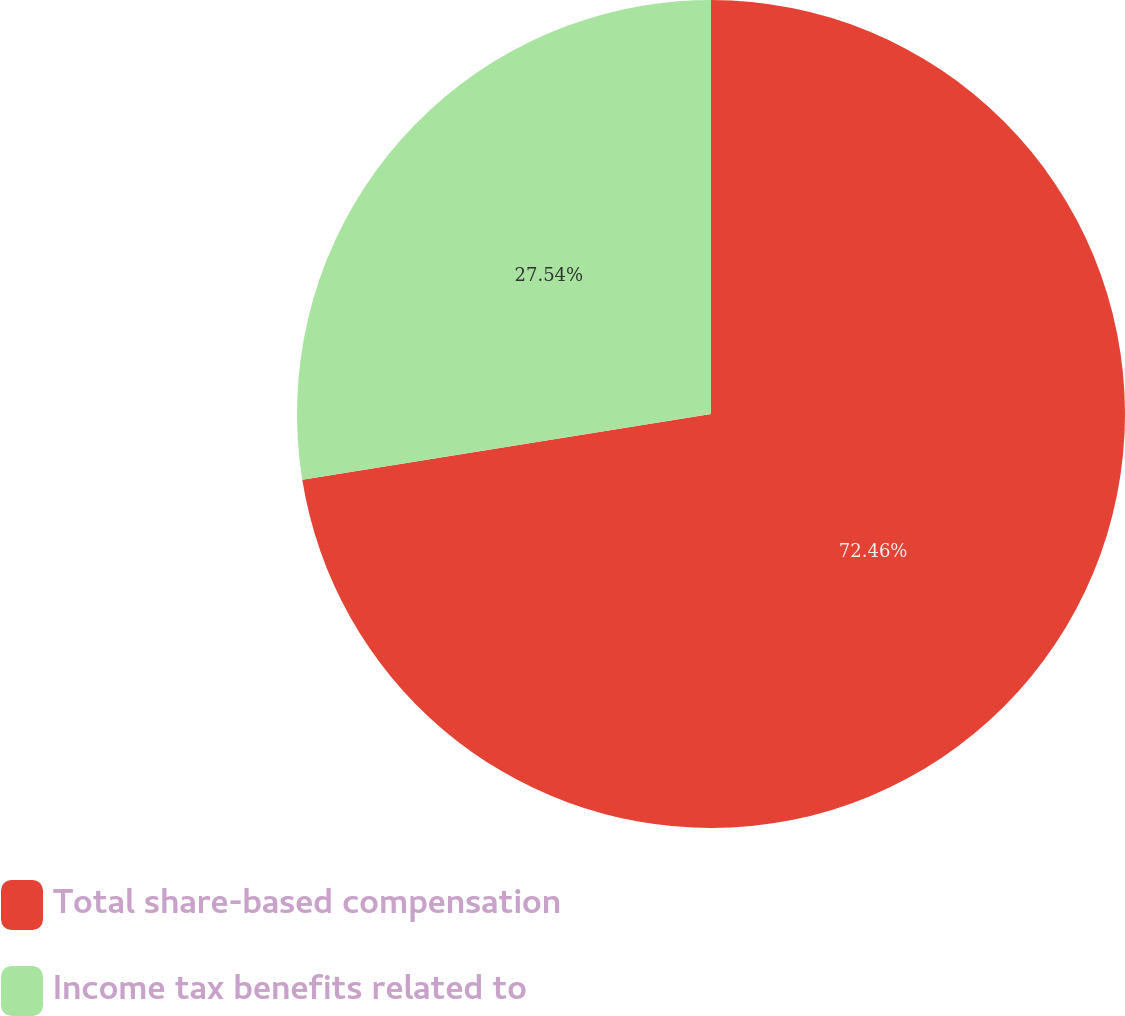<chart> <loc_0><loc_0><loc_500><loc_500><pie_chart><fcel>Total share-based compensation<fcel>Income tax benefits related to<nl><fcel>72.46%<fcel>27.54%<nl></chart> 